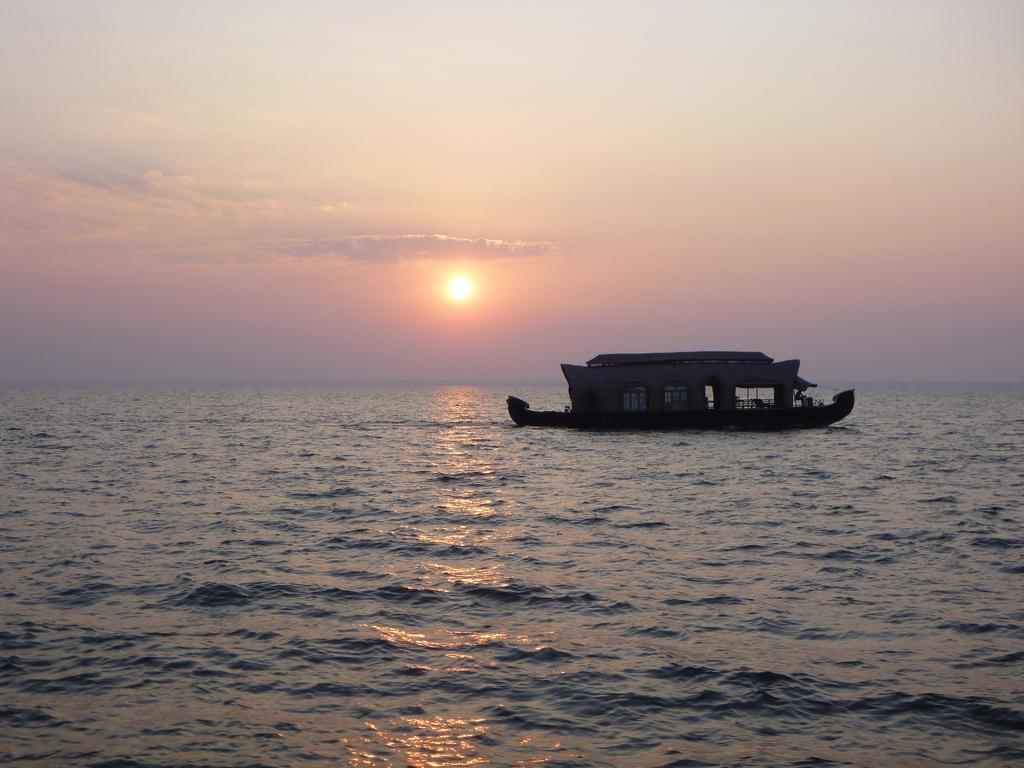Could you give a brief overview of what you see in this image? In this image I can see the water and a boat on the surface of the water. In the background I can see the sky and the sun. 